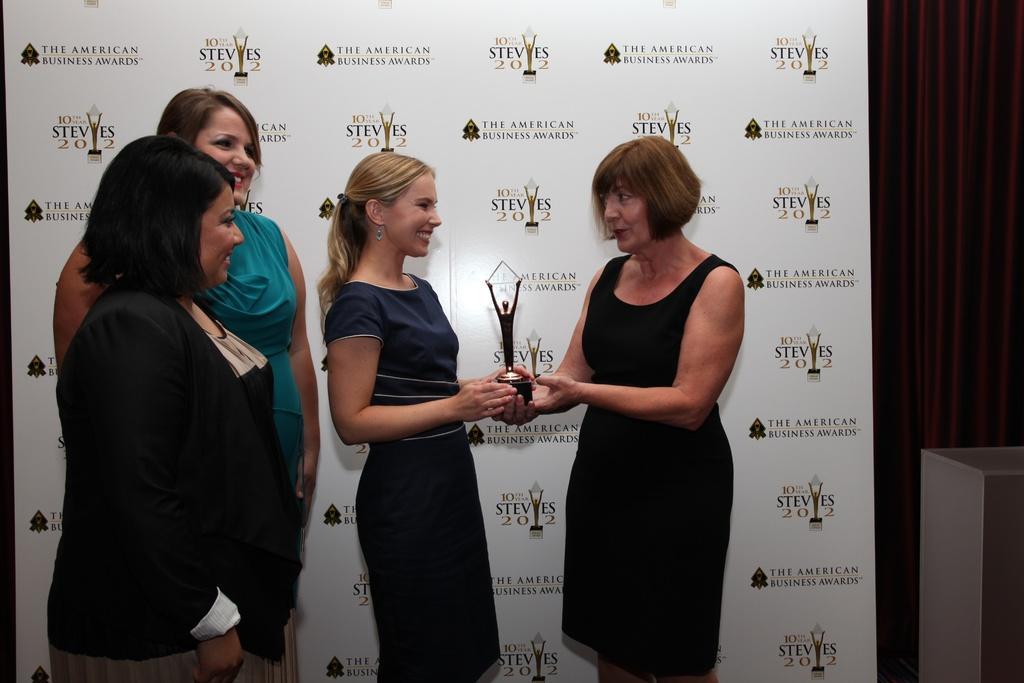In one or two sentences, can you explain what this image depicts? In the image we can see four women standing, they are wearing clothes. This is a trophy, ear stud and a poster. 